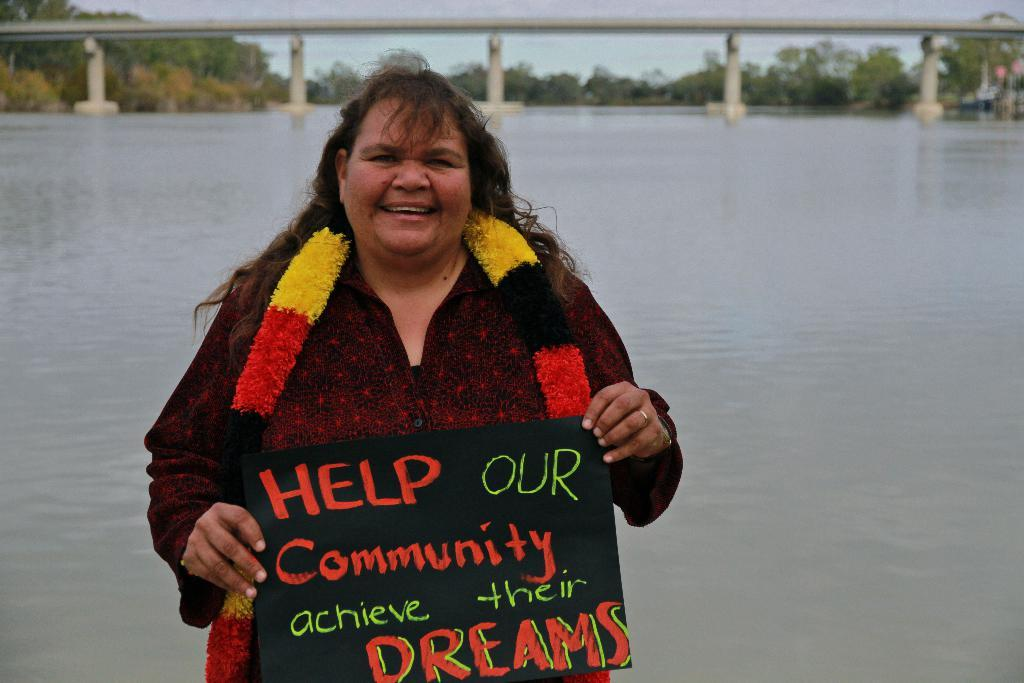Who is present in the image? There is a woman in the image. What is the woman holding in the image? The woman is holding a board. What can be seen on the board? There is writing on the board. What can be seen in the background of the image? There is a lake, a bridge, trees, and the sky visible in the background of the image. What type of furniture can be seen floating in space in the image? There is no furniture or space present in the image; it features a woman holding a board with writing on it, and the background includes a lake, bridge, trees, and the sky. 